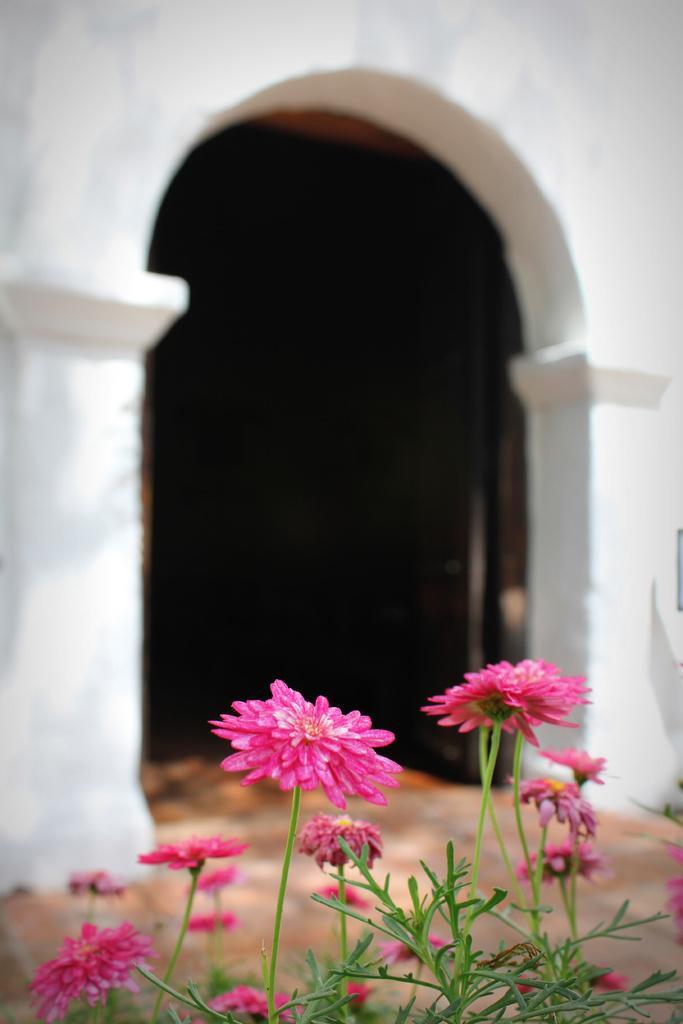Could you give a brief overview of what you see in this image? In this picture there are pink color flowers on the plant. At the back there is a building and there is a door. 